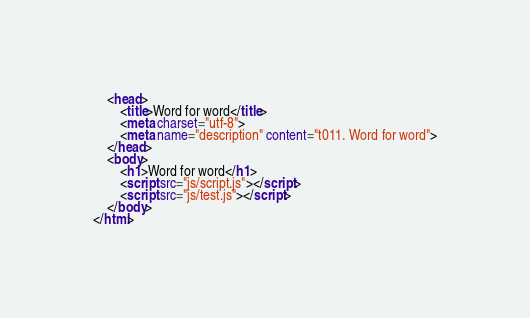<code> <loc_0><loc_0><loc_500><loc_500><_HTML_>    <head>
        <title>Word for word</title>
        <meta charset="utf-8">
        <meta name="description" content="t011. Word for word">
    </head>
    <body>
        <h1>Word for word</h1>
        <script src="js/script.js"></script>
        <script src="js/test.js"></script>
    </body>
</html>
</code> 